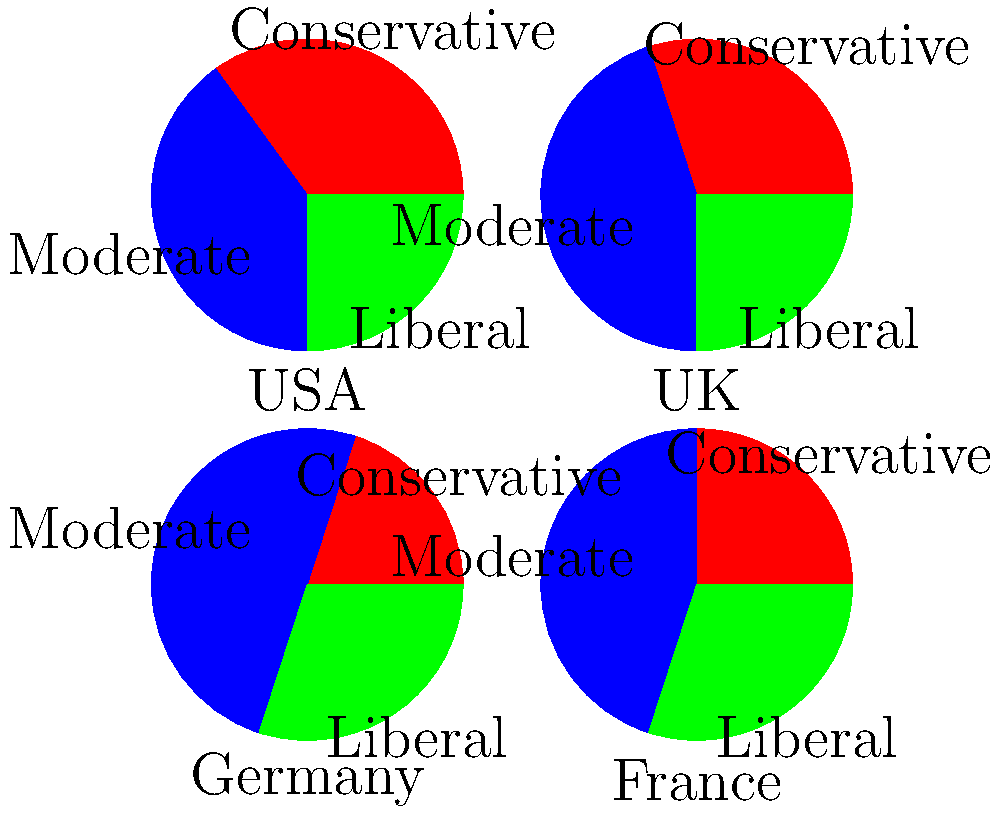Analyze the pie charts representing the distribution of political ideologies in the USA, UK, Germany, and France. Which country shows the highest percentage of moderates, and how does this compare to the distribution in other countries? Critically assess the implications of these distributions on each country's political landscape. To answer this question, we need to follow these steps:

1. Identify the percentage of moderates in each country:
   USA: 40%
   UK: 45%
   Germany: 50%
   France: 45%

2. Determine which country has the highest percentage of moderates:
   Germany has the highest at 50%.

3. Compare Germany's moderate percentage to other countries:
   - Germany (50%) is 10 percentage points higher than the USA (40%)
   - Germany (50%) is 5 percentage points higher than both the UK and France (45% each)

4. Analyze the implications:
   a) Germany's high moderate percentage suggests a more centrist political landscape, potentially leading to:
      - Greater political stability
      - More compromise in policy-making
      - Difficulty for extreme ideologies to gain traction

   b) The USA has the lowest moderate percentage (40%), indicating:
      - A more polarized political environment
      - Potential for greater political gridlock
      - Stronger influence of conservative and liberal ideologies on policy

   c) The UK and France have identical moderate percentages (45%), but different conservative-liberal splits:
      - UK: More conservatives (30%) than liberals (25%)
      - France: More liberals (30%) than conservatives (25%)
      This could lead to slightly different policy orientations despite similar moderate bases.

5. Critical assessment:
   - The data presented is simplified and may not capture the full complexity of political ideologies in these countries.
   - The definitions of "conservative," "moderate," and "liberal" may vary between countries and political systems.
   - These distributions could be influenced by various factors such as historical context, economic conditions, and current events, which are not captured in the pie charts.
   - The impact of these distributions on actual policy outcomes may be moderated by each country's specific political system and institutions.
Answer: Germany has the highest percentage of moderates at 50%, exceeding other countries by 5-10 percentage points. This suggests a more centrist political landscape in Germany, potentially leading to greater stability and compromise, while countries like the USA may experience more polarization and political gridlock. 